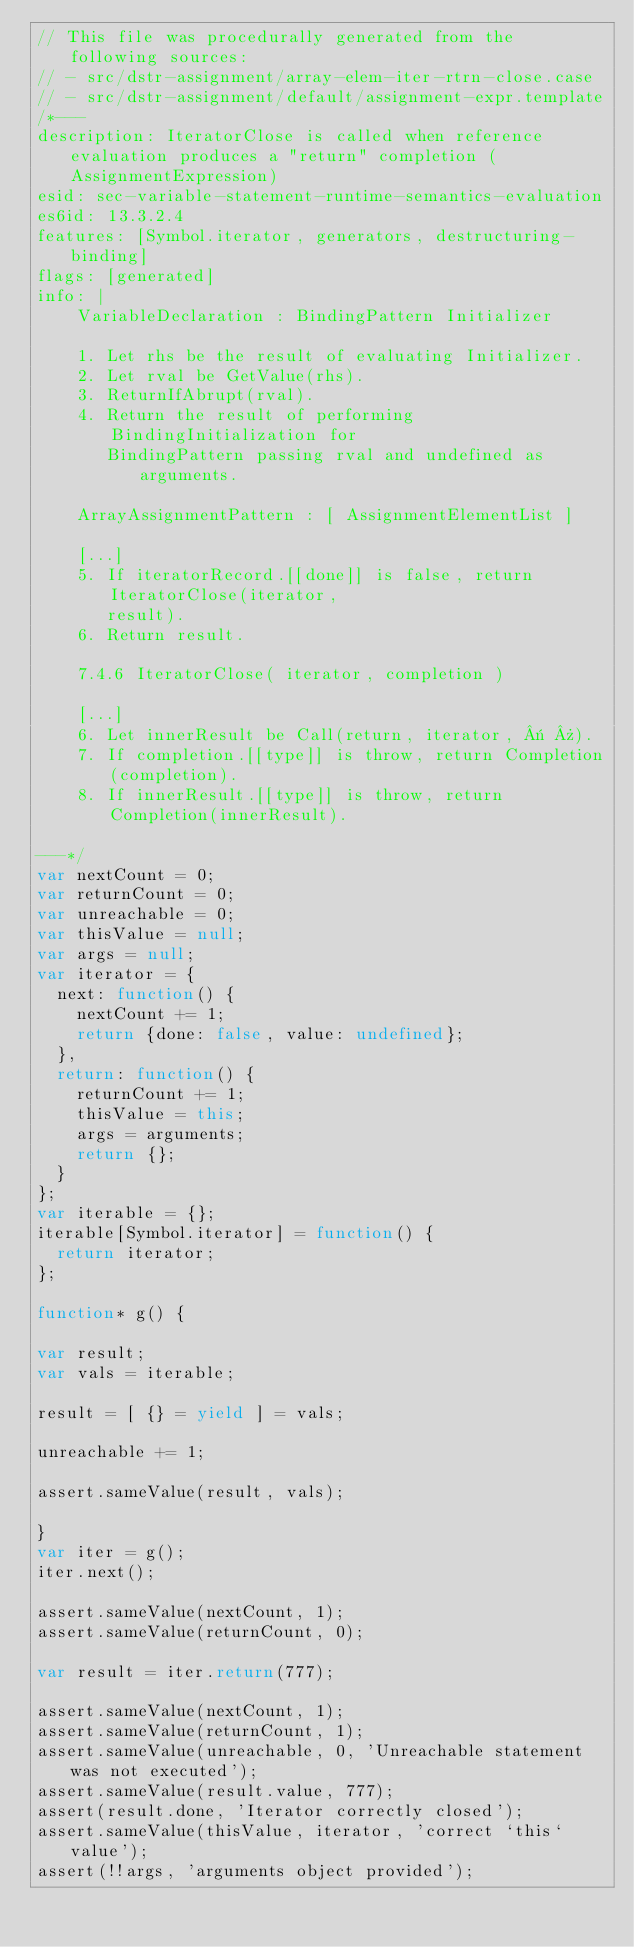Convert code to text. <code><loc_0><loc_0><loc_500><loc_500><_JavaScript_>// This file was procedurally generated from the following sources:
// - src/dstr-assignment/array-elem-iter-rtrn-close.case
// - src/dstr-assignment/default/assignment-expr.template
/*---
description: IteratorClose is called when reference evaluation produces a "return" completion (AssignmentExpression)
esid: sec-variable-statement-runtime-semantics-evaluation
es6id: 13.3.2.4
features: [Symbol.iterator, generators, destructuring-binding]
flags: [generated]
info: |
    VariableDeclaration : BindingPattern Initializer

    1. Let rhs be the result of evaluating Initializer.
    2. Let rval be GetValue(rhs).
    3. ReturnIfAbrupt(rval).
    4. Return the result of performing BindingInitialization for
       BindingPattern passing rval and undefined as arguments.

    ArrayAssignmentPattern : [ AssignmentElementList ]

    [...]
    5. If iteratorRecord.[[done]] is false, return IteratorClose(iterator,
       result).
    6. Return result.

    7.4.6 IteratorClose( iterator, completion )

    [...]
    6. Let innerResult be Call(return, iterator, « »).
    7. If completion.[[type]] is throw, return Completion(completion).
    8. If innerResult.[[type]] is throw, return Completion(innerResult).

---*/
var nextCount = 0;
var returnCount = 0;
var unreachable = 0;
var thisValue = null;
var args = null;
var iterator = {
  next: function() {
    nextCount += 1;
    return {done: false, value: undefined};
  },
  return: function() {
    returnCount += 1;
    thisValue = this;
    args = arguments;
    return {};
  }
};
var iterable = {};
iterable[Symbol.iterator] = function() {
  return iterator;
};

function* g() {

var result;
var vals = iterable;

result = [ {} = yield ] = vals;

unreachable += 1;

assert.sameValue(result, vals);

}
var iter = g();
iter.next();

assert.sameValue(nextCount, 1);
assert.sameValue(returnCount, 0);

var result = iter.return(777);

assert.sameValue(nextCount, 1);
assert.sameValue(returnCount, 1);
assert.sameValue(unreachable, 0, 'Unreachable statement was not executed');
assert.sameValue(result.value, 777);
assert(result.done, 'Iterator correctly closed');
assert.sameValue(thisValue, iterator, 'correct `this` value');
assert(!!args, 'arguments object provided');</code> 